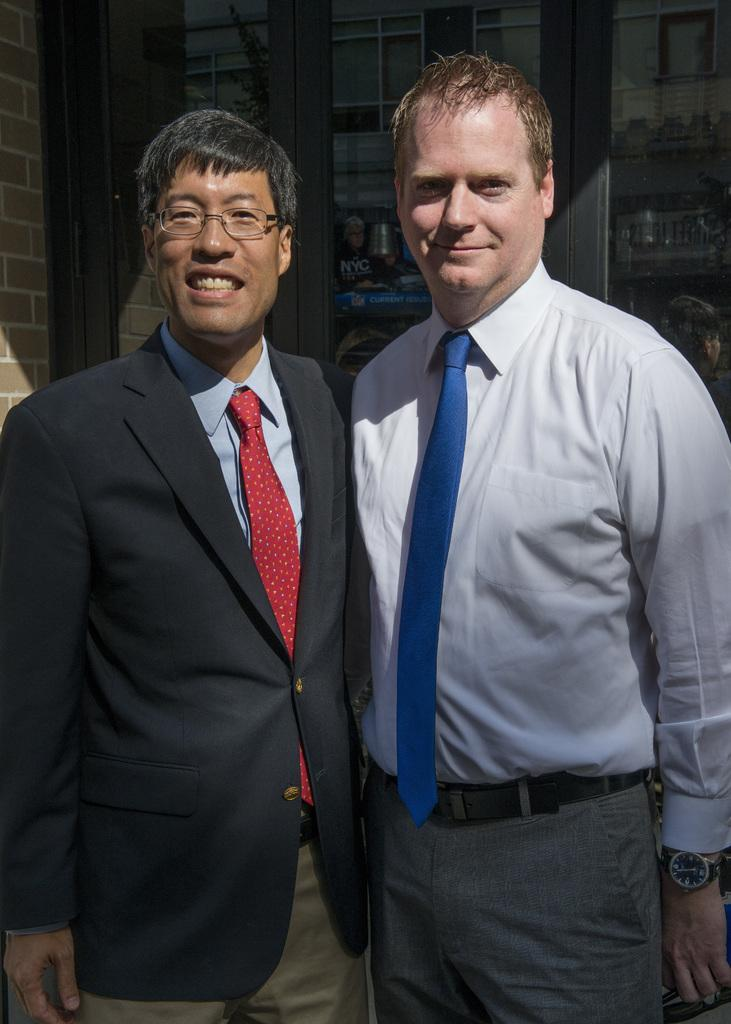How many people are in the image? There are two persons standing in the image. What expressions do the people have on their faces? The persons are wearing smiles on their faces. What can be seen in the background of the image? There is a window visible in the background of the image. What type of shelf can be seen in the image? There is no shelf present in the image. Can you tell me how many toes are visible on the persons' feet in the image? The image does not provide information about the persons' feet, so it is not possible to determine the number of visible toes. 